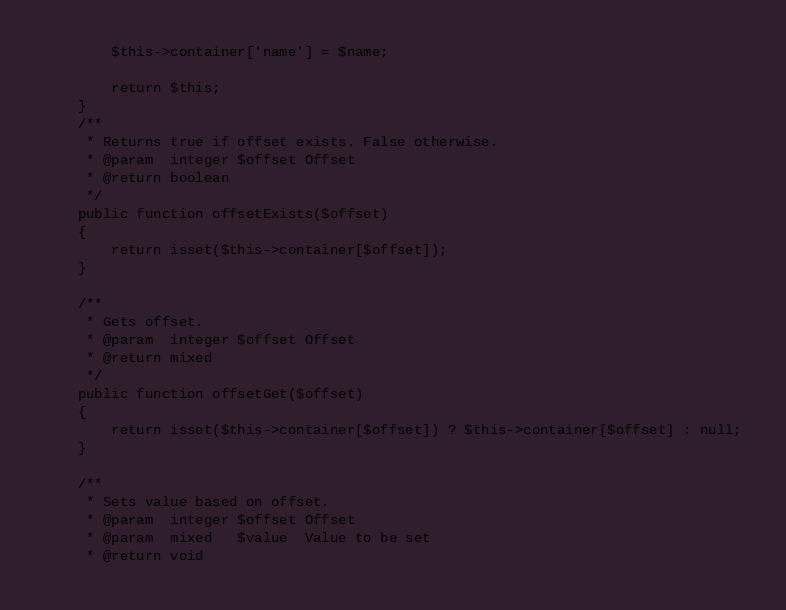<code> <loc_0><loc_0><loc_500><loc_500><_PHP_>        $this->container['name'] = $name;

        return $this;
    }
    /**
     * Returns true if offset exists. False otherwise.
     * @param  integer $offset Offset
     * @return boolean
     */
    public function offsetExists($offset)
    {
        return isset($this->container[$offset]);
    }

    /**
     * Gets offset.
     * @param  integer $offset Offset
     * @return mixed
     */
    public function offsetGet($offset)
    {
        return isset($this->container[$offset]) ? $this->container[$offset] : null;
    }

    /**
     * Sets value based on offset.
     * @param  integer $offset Offset
     * @param  mixed   $value  Value to be set
     * @return void</code> 